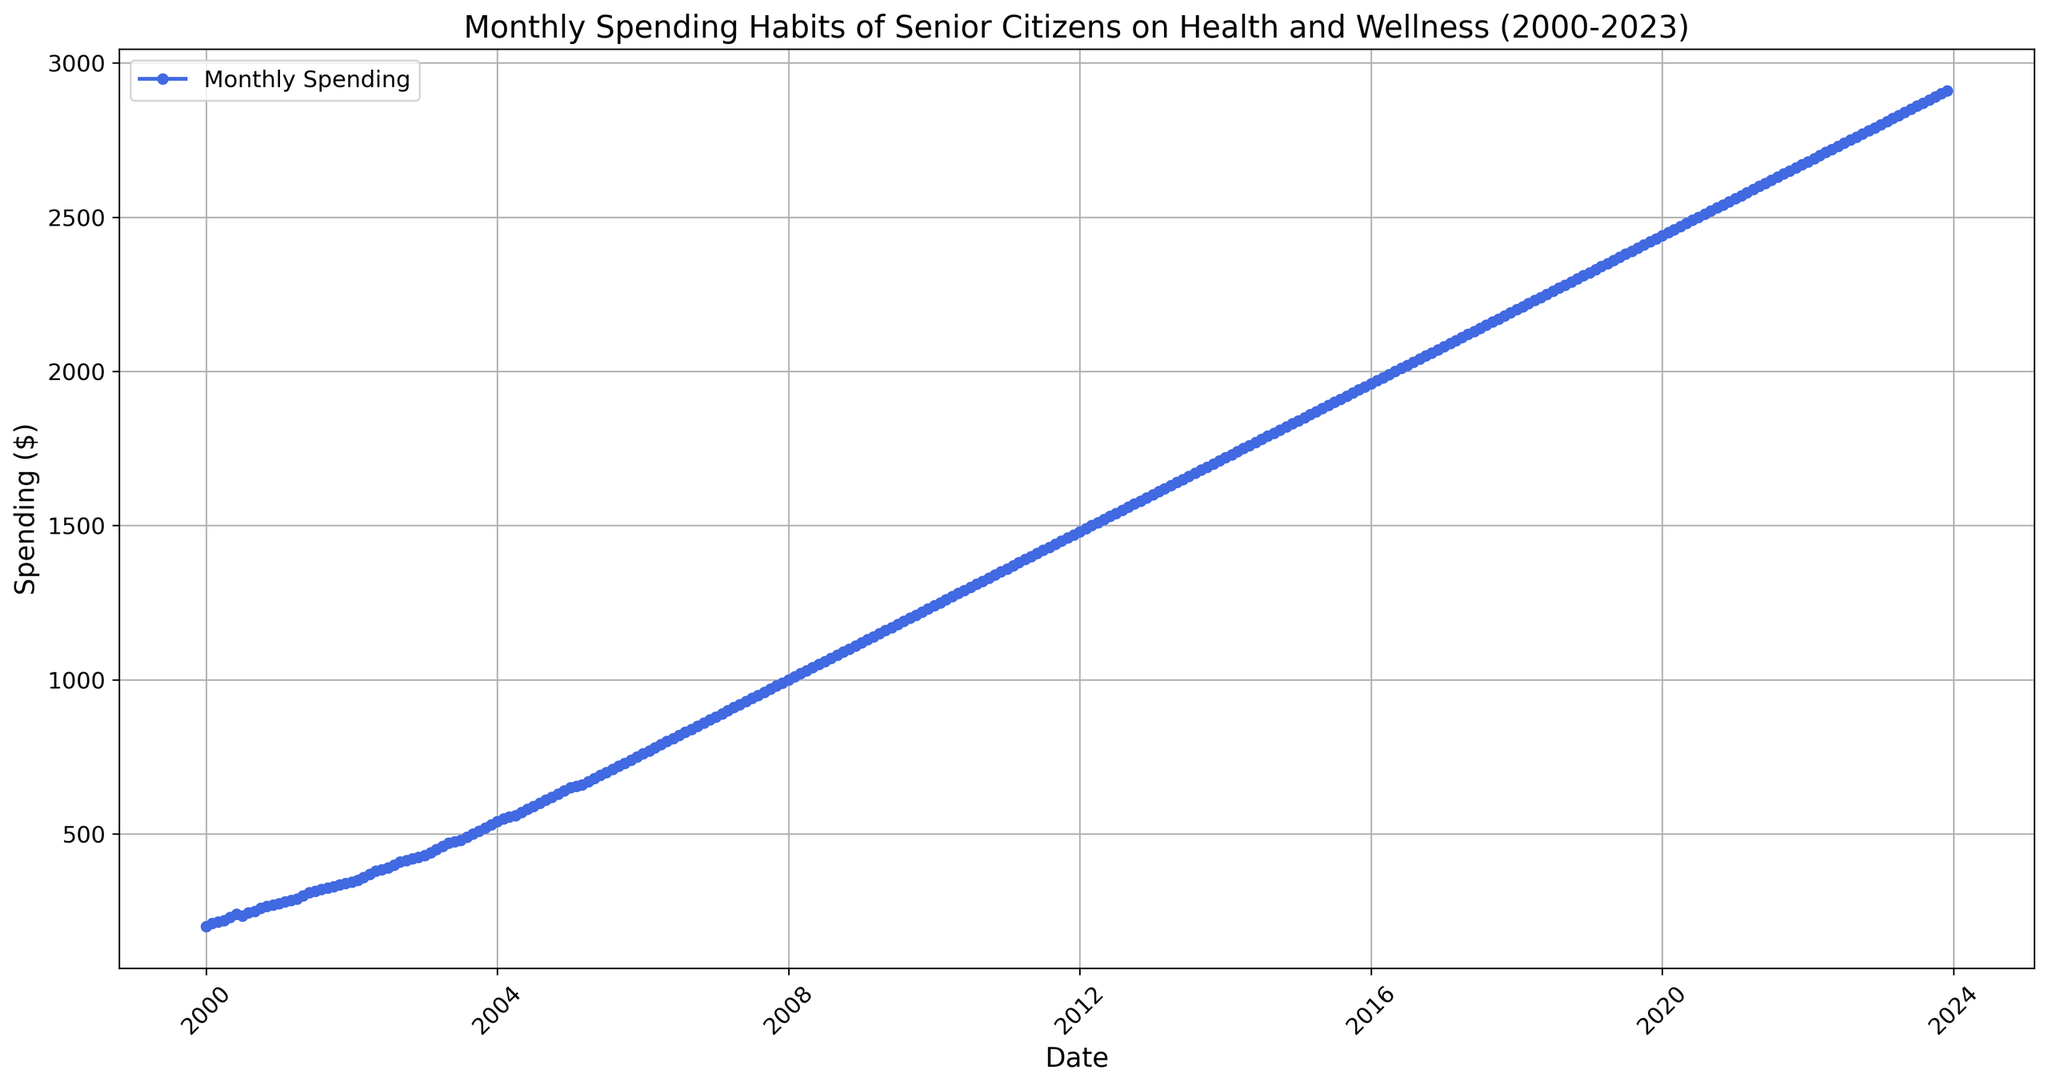What's the highest monthly spending seen in the chart? The highest spending is at the end of the chart in December 2023, where the spending is clearly the uppermost point on the graph.
Answer: $2910 What was the spending in January 2008, and how much did it increase by December 2008? In January 2008, the spending was $1000. By December 2008, the spending increased to $1110. The increase over the year is $1110 - $1000 = $110.
Answer: $110 How does the spending in January 2010 compare to January 2020? In January 2010, the spending was $1240. In January 2020, the spending was $2440. 2020's spending was significantly greater, with a difference of $2440 - $1240 = $1200.
Answer: $1200 What is the general trend of monthly spending from 2000 to 2023? From 2000 to 2023, the general trend of monthly spending is an upward one. Every few months, the spending amount increases steadily and continuously throughout the period.
Answer: Upward trend How much did the spending increase every decade, from 2000 to 2010, and then from 2010 to 2020? From January 2000 ($200) to January 2010 ($1240), the increase was $1240 - $200 = $1040. From January 2010 ($1240) to January 2020 ($2440), the increase was $2440 - $1240 = $1200.
Answer: $1040, $1200 Around what years did the monthly spending reach $1500? The monthly spending reached $1500 around March 2012. This point can be located where the spending line crosses the $1500 mark.
Answer: March 2012 Is there any noticeable flattening or decline in the spending curve at any period from 2000 to 2023? The spending curve appears to be consistently increasing; hence there is no significant flattening or declining period through 2000 to 2023.
Answer: No flattening or decline During which year did the spending increase the most in one single year? In 2008, the spending increased from $1000 to $1110, a $110 increase, which is visually the steepest single-year rise on the graph.
Answer: 2008 